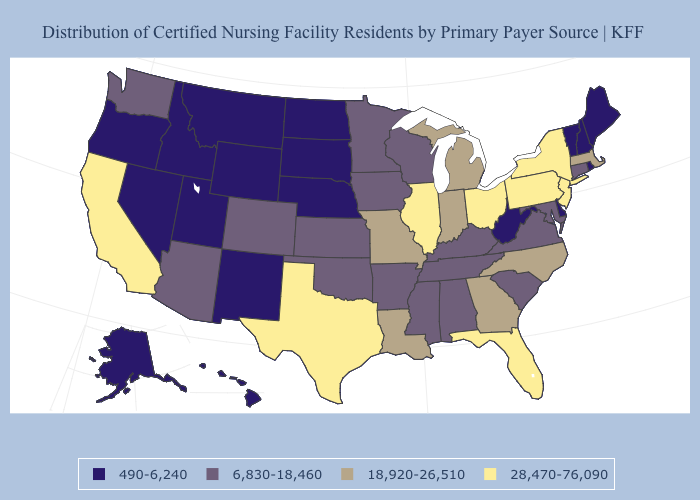What is the value of West Virginia?
Keep it brief. 490-6,240. Does Pennsylvania have the highest value in the USA?
Be succinct. Yes. Among the states that border Florida , does Alabama have the lowest value?
Be succinct. Yes. Name the states that have a value in the range 28,470-76,090?
Answer briefly. California, Florida, Illinois, New Jersey, New York, Ohio, Pennsylvania, Texas. Name the states that have a value in the range 490-6,240?
Concise answer only. Alaska, Delaware, Hawaii, Idaho, Maine, Montana, Nebraska, Nevada, New Hampshire, New Mexico, North Dakota, Oregon, Rhode Island, South Dakota, Utah, Vermont, West Virginia, Wyoming. Among the states that border New Mexico , does Utah have the highest value?
Concise answer only. No. What is the highest value in the USA?
Give a very brief answer. 28,470-76,090. Name the states that have a value in the range 490-6,240?
Give a very brief answer. Alaska, Delaware, Hawaii, Idaho, Maine, Montana, Nebraska, Nevada, New Hampshire, New Mexico, North Dakota, Oregon, Rhode Island, South Dakota, Utah, Vermont, West Virginia, Wyoming. Among the states that border Utah , does Arizona have the lowest value?
Concise answer only. No. Which states have the lowest value in the South?
Short answer required. Delaware, West Virginia. Name the states that have a value in the range 6,830-18,460?
Short answer required. Alabama, Arizona, Arkansas, Colorado, Connecticut, Iowa, Kansas, Kentucky, Maryland, Minnesota, Mississippi, Oklahoma, South Carolina, Tennessee, Virginia, Washington, Wisconsin. Does Illinois have the lowest value in the MidWest?
Concise answer only. No. Name the states that have a value in the range 18,920-26,510?
Answer briefly. Georgia, Indiana, Louisiana, Massachusetts, Michigan, Missouri, North Carolina. What is the value of Maryland?
Quick response, please. 6,830-18,460. Does the map have missing data?
Short answer required. No. 